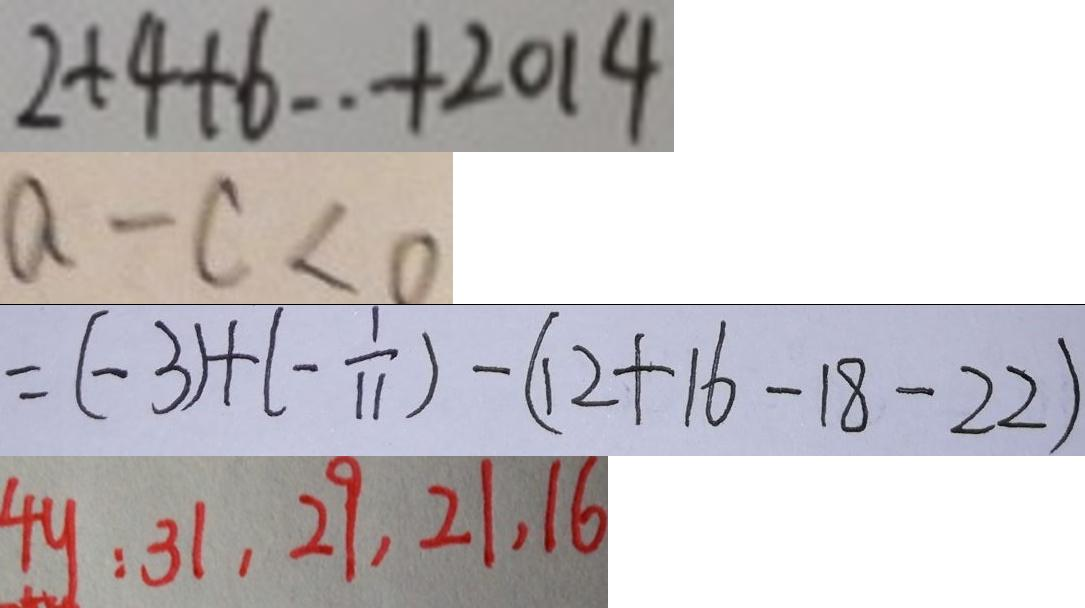<formula> <loc_0><loc_0><loc_500><loc_500>2 + 4 + 6 \cdot + 2 0 1 4 
 a - c < 0 
 = ( - 3 ) + ( - \frac { 1 } { 1 1 } ) - ( 1 2 + 1 6 - 1 8 - 2 2 ) 
 4 y : 3 1 , 2 9 , 2 1 , 1 6</formula> 